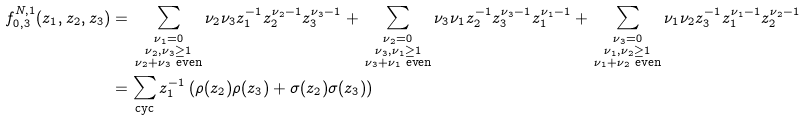<formula> <loc_0><loc_0><loc_500><loc_500>f _ { 0 , 3 } ^ { N , 1 } ( z _ { 1 } , z _ { 2 } , z _ { 3 } ) & = \, \sum _ { \substack { \nu _ { 1 } = 0 \\ \nu _ { 2 } , \nu _ { 3 } \geq 1 \\ \nu _ { 2 } + \nu _ { 3 } \text { even} } } \nu _ { 2 } \nu _ { 3 } z _ { 1 } ^ { - 1 } z _ { 2 } ^ { \nu _ { 2 } - 1 } z _ { 3 } ^ { \nu _ { 3 } - 1 } + \, \sum _ { \substack { \nu _ { 2 } = 0 \\ \nu _ { 3 } , \nu _ { 1 } \geq 1 \\ \nu _ { 3 } + \nu _ { 1 } \text { even} } } \nu _ { 3 } \nu _ { 1 } z _ { 2 } ^ { - 1 } z _ { 3 } ^ { \nu _ { 3 } - 1 } z _ { 1 } ^ { \nu _ { 1 } - 1 } + \, \sum _ { \substack { \nu _ { 3 } = 0 \\ \nu _ { 1 } , \nu _ { 2 } \geq 1 \\ \nu _ { 1 } + \nu _ { 2 } \text { even} } } \nu _ { 1 } \nu _ { 2 } z _ { 3 } ^ { - 1 } z _ { 1 } ^ { \nu _ { 1 } - 1 } z _ { 2 } ^ { \nu _ { 2 } - 1 } \\ & = \sum _ { \text {cyc} } z _ { 1 } ^ { - 1 } \left ( \rho ( z _ { 2 } ) \rho ( z _ { 3 } ) + \sigma ( z _ { 2 } ) \sigma ( z _ { 3 } ) \right )</formula> 